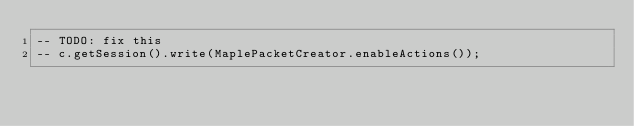<code> <loc_0><loc_0><loc_500><loc_500><_Lua_>-- TODO: fix this
-- c.getSession().write(MaplePacketCreator.enableActions());</code> 